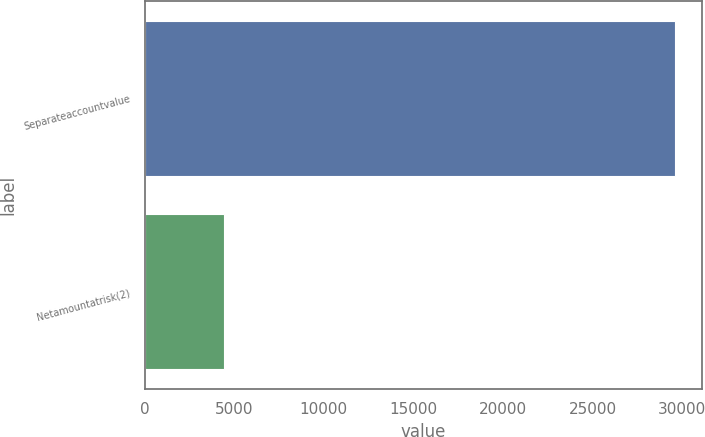<chart> <loc_0><loc_0><loc_500><loc_500><bar_chart><fcel>Separateaccountvalue<fcel>Netamountatrisk(2)<nl><fcel>29603<fcel>4414<nl></chart> 